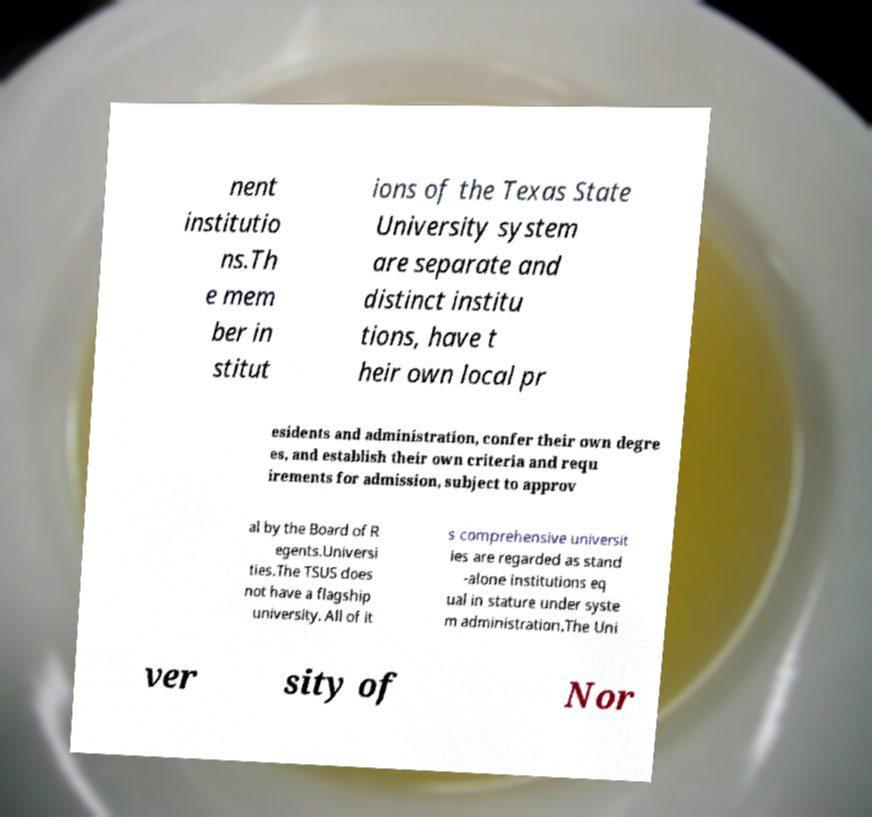What messages or text are displayed in this image? I need them in a readable, typed format. nent institutio ns.Th e mem ber in stitut ions of the Texas State University system are separate and distinct institu tions, have t heir own local pr esidents and administration, confer their own degre es, and establish their own criteria and requ irements for admission, subject to approv al by the Board of R egents.Universi ties.The TSUS does not have a flagship university. All of it s comprehensive universit ies are regarded as stand -alone institutions eq ual in stature under syste m administration.The Uni ver sity of Nor 